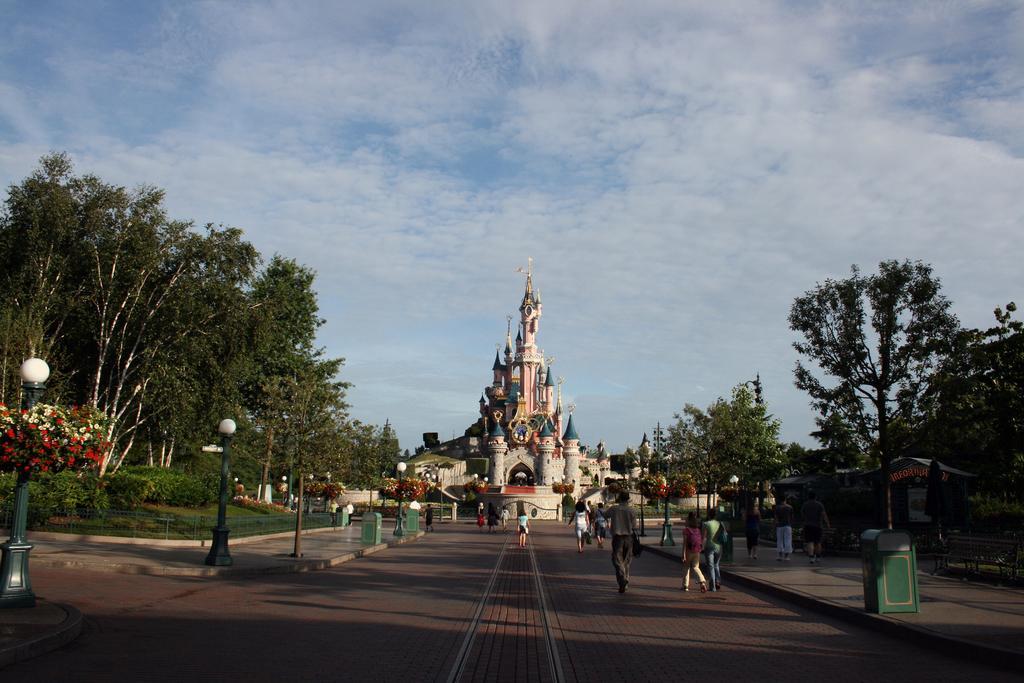How would you summarize this image in a sentence or two? In this picture there is a building and there are trees and street lights and there are dustbins on the footpath. There are group of people walking on the road. At the top there is sky and there are clouds. At the bottom there is a road. 